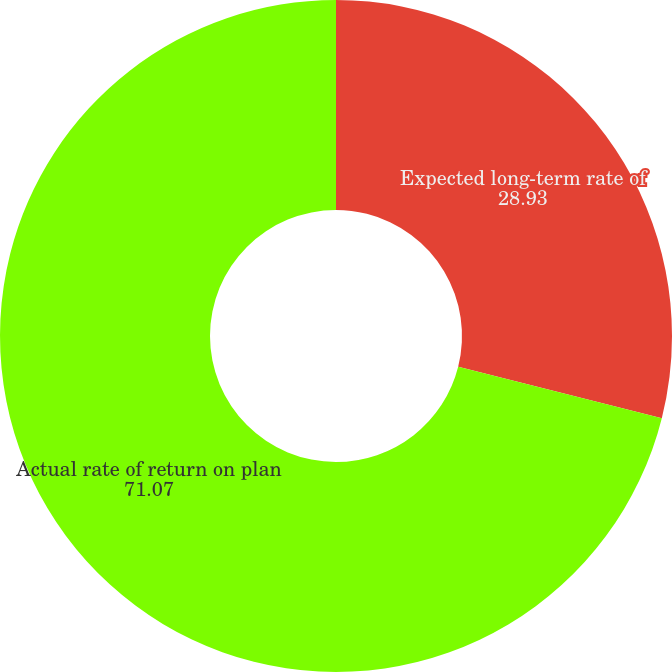Convert chart to OTSL. <chart><loc_0><loc_0><loc_500><loc_500><pie_chart><fcel>Expected long-term rate of<fcel>Actual rate of return on plan<nl><fcel>28.93%<fcel>71.07%<nl></chart> 